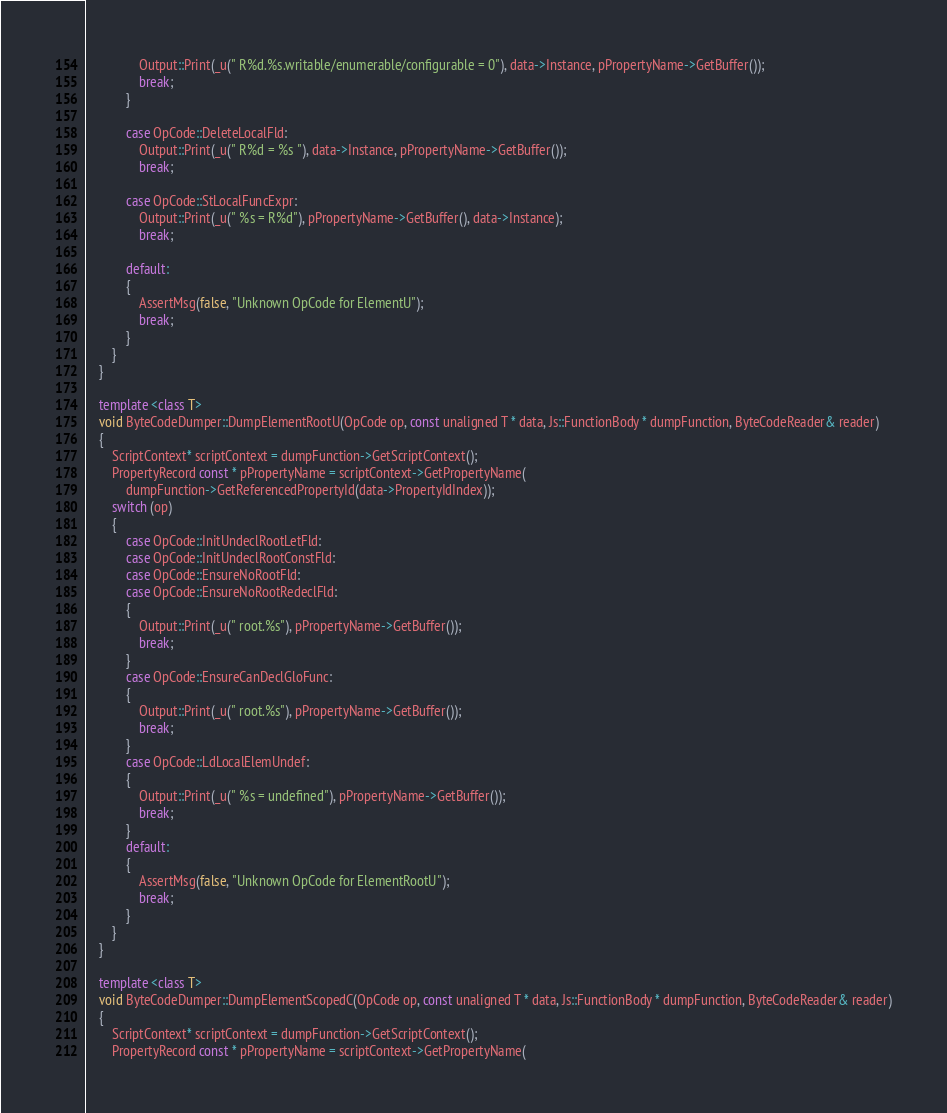Convert code to text. <code><loc_0><loc_0><loc_500><loc_500><_C++_>                Output::Print(_u(" R%d.%s.writable/enumerable/configurable = 0"), data->Instance, pPropertyName->GetBuffer());
                break;
            }

            case OpCode::DeleteLocalFld:
                Output::Print(_u(" R%d = %s "), data->Instance, pPropertyName->GetBuffer());
                break;

            case OpCode::StLocalFuncExpr:
                Output::Print(_u(" %s = R%d"), pPropertyName->GetBuffer(), data->Instance);
                break;

            default:
            {
                AssertMsg(false, "Unknown OpCode for ElementU");
                break;
            }
        }
    }

    template <class T>
    void ByteCodeDumper::DumpElementRootU(OpCode op, const unaligned T * data, Js::FunctionBody * dumpFunction, ByteCodeReader& reader)
    {
        ScriptContext* scriptContext = dumpFunction->GetScriptContext();
        PropertyRecord const * pPropertyName = scriptContext->GetPropertyName(
            dumpFunction->GetReferencedPropertyId(data->PropertyIdIndex));
        switch (op)
        {
            case OpCode::InitUndeclRootLetFld:
            case OpCode::InitUndeclRootConstFld:
            case OpCode::EnsureNoRootFld:
            case OpCode::EnsureNoRootRedeclFld:
            {
                Output::Print(_u(" root.%s"), pPropertyName->GetBuffer());
                break;
            }
            case OpCode::EnsureCanDeclGloFunc:
            {
                Output::Print(_u(" root.%s"), pPropertyName->GetBuffer());
                break;
            }
            case OpCode::LdLocalElemUndef:
            {
                Output::Print(_u(" %s = undefined"), pPropertyName->GetBuffer());
                break;
            }
            default:
            {
                AssertMsg(false, "Unknown OpCode for ElementRootU");
                break;
            }
        }
    }

    template <class T>
    void ByteCodeDumper::DumpElementScopedC(OpCode op, const unaligned T * data, Js::FunctionBody * dumpFunction, ByteCodeReader& reader)
    {
        ScriptContext* scriptContext = dumpFunction->GetScriptContext();
        PropertyRecord const * pPropertyName = scriptContext->GetPropertyName(</code> 